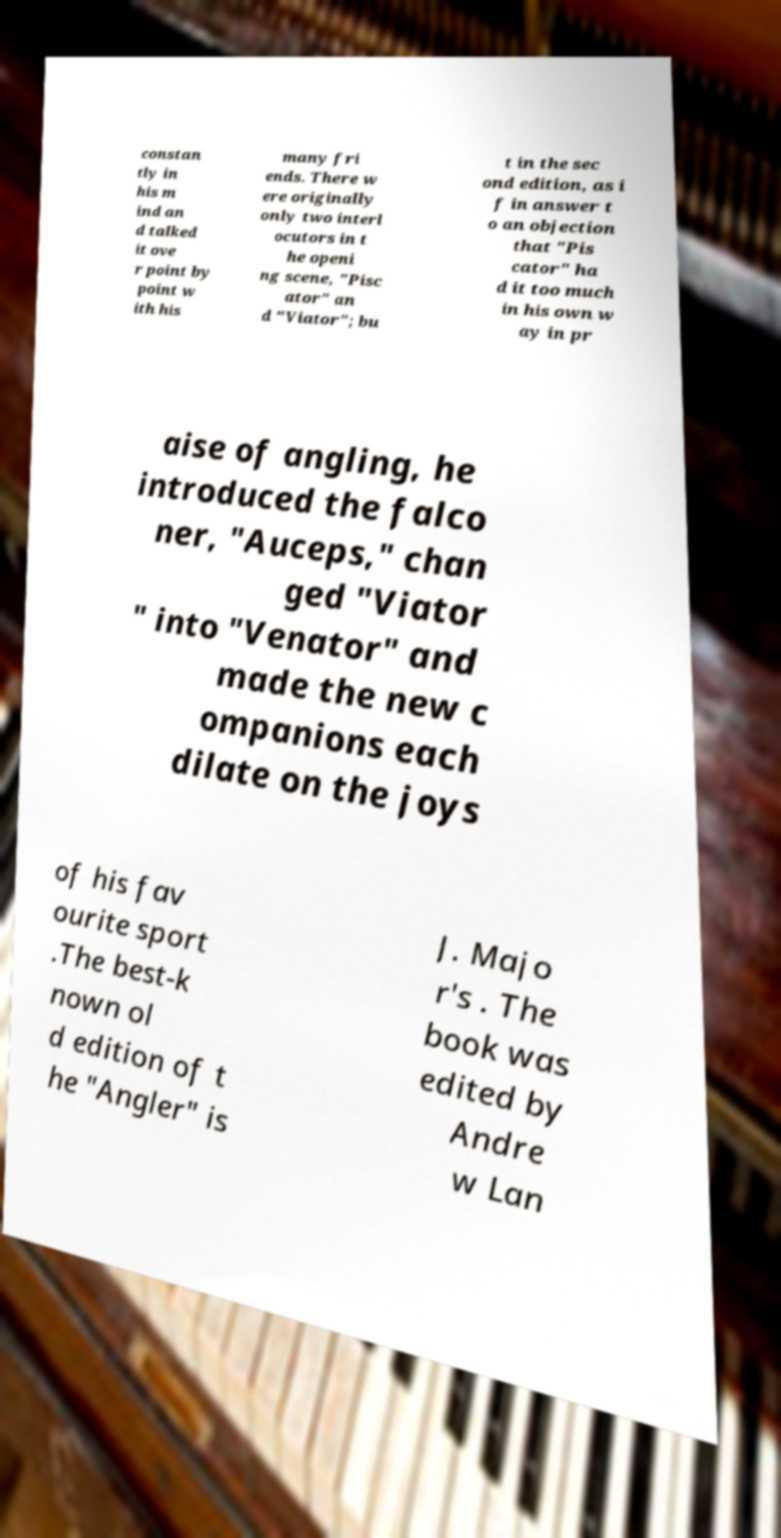Can you accurately transcribe the text from the provided image for me? constan tly in his m ind an d talked it ove r point by point w ith his many fri ends. There w ere originally only two interl ocutors in t he openi ng scene, "Pisc ator" an d "Viator"; bu t in the sec ond edition, as i f in answer t o an objection that "Pis cator" ha d it too much in his own w ay in pr aise of angling, he introduced the falco ner, "Auceps," chan ged "Viator " into "Venator" and made the new c ompanions each dilate on the joys of his fav ourite sport .The best-k nown ol d edition of t he "Angler" is J. Majo r's . The book was edited by Andre w Lan 